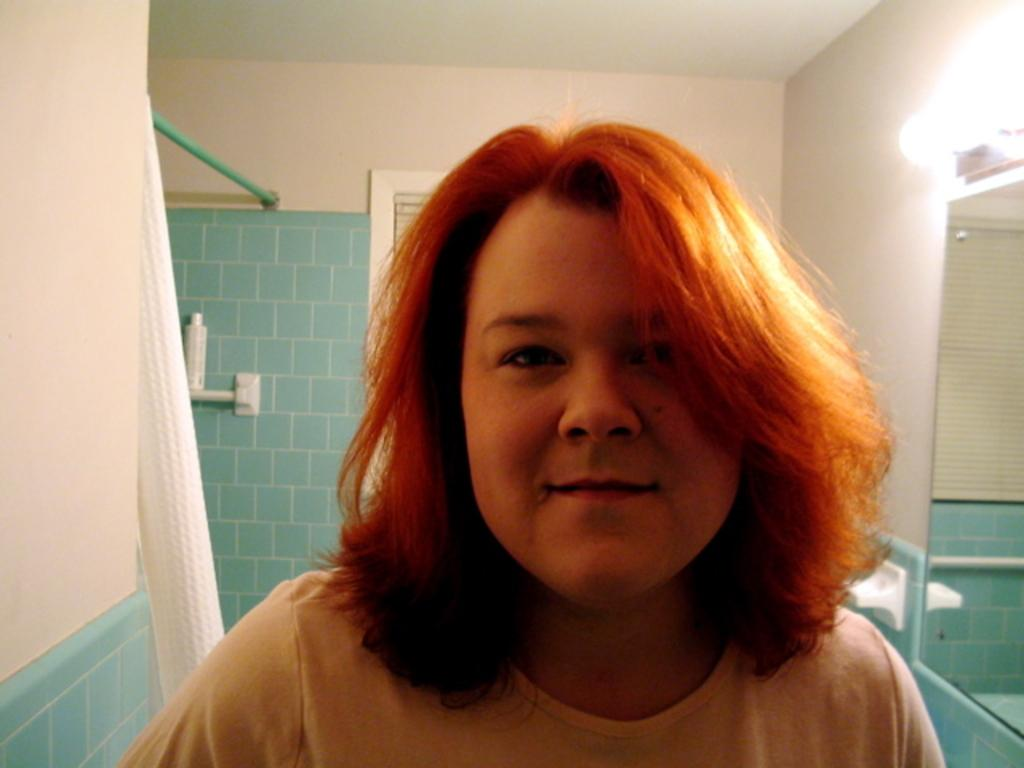What is the person in the image wearing? The person in the image is wearing a dress. What is located to the right of the person? There is a mirror and a light on the wall to the right of the person. What is located to the left of the person? There is a bottle and a curtain to the left of the person. What type of reward is the person receiving from the committee in the image? There is no committee or reward present in the image; it only features a person wearing a dress, a mirror, a light, a bottle, and a curtain. 